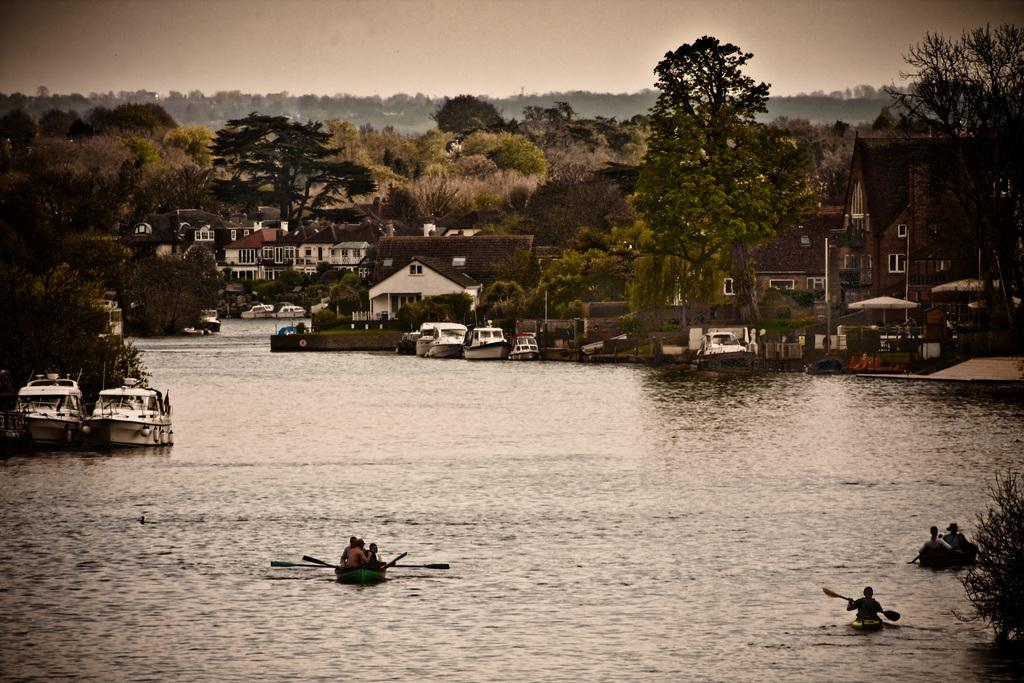What type of vehicles can be seen in the image? There are fleets of boats in the image. What are the people in the water doing? There is a group of people in the water, but their activity is not specified. What type of vegetation is visible in the image? Plants and trees are visible in the image. What type of structures are present in the image? Houses and buildings are in the image. What part of the natural environment is visible in the image? The sky is visible in the image. Can you describe the setting where the image might have been taken? The image may have been taken near a lake, based on the presence of boats and water. What type of bait is being used by the birds in the image? There are no birds present in the image, so it is not possible to determine what type of bait they might be using. How many turkeys can be seen in the image? There are no turkeys present in the image, so it is not possible to determine their number. 